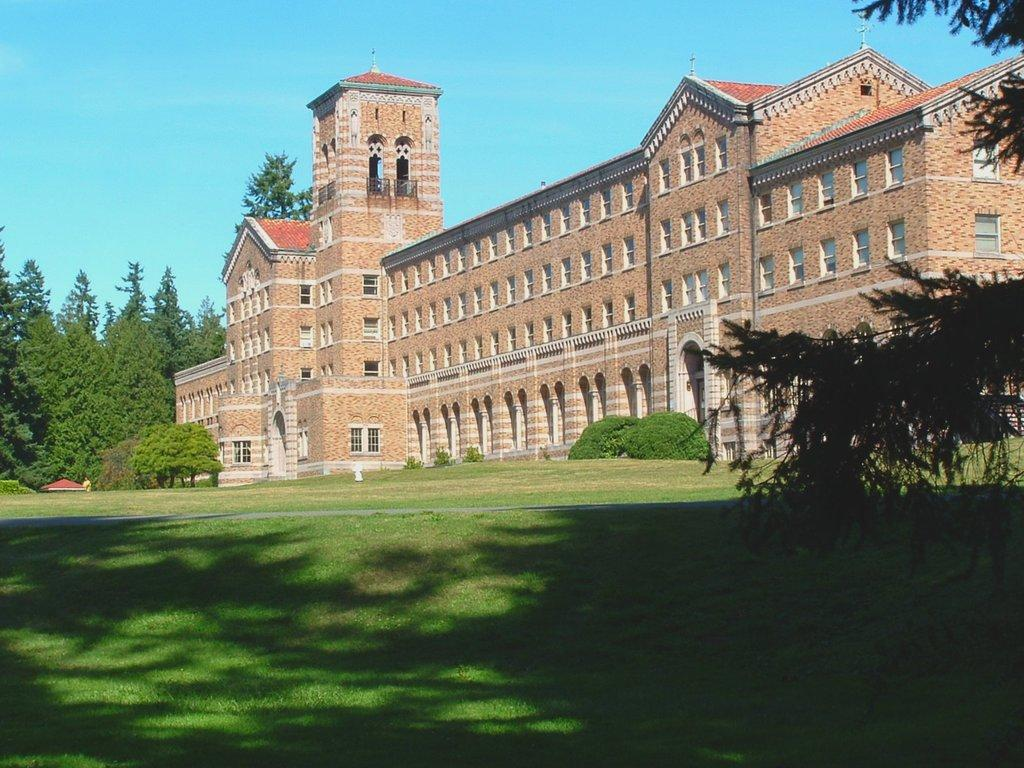What type of vegetation is present on the ground in the front of the image? There is grass on the ground in the front of the image. What can be seen on the right side of the image? There are leaves on the right side of the image. What type of structure is visible in the background of the image? There is a castle in the background of the image. What other natural elements are present in the background of the image? There are trees in the background of the image. What type of apparatus is being used by the sheep in the image? There are no sheep present in the image, and therefore no apparatus can be associated with them. 